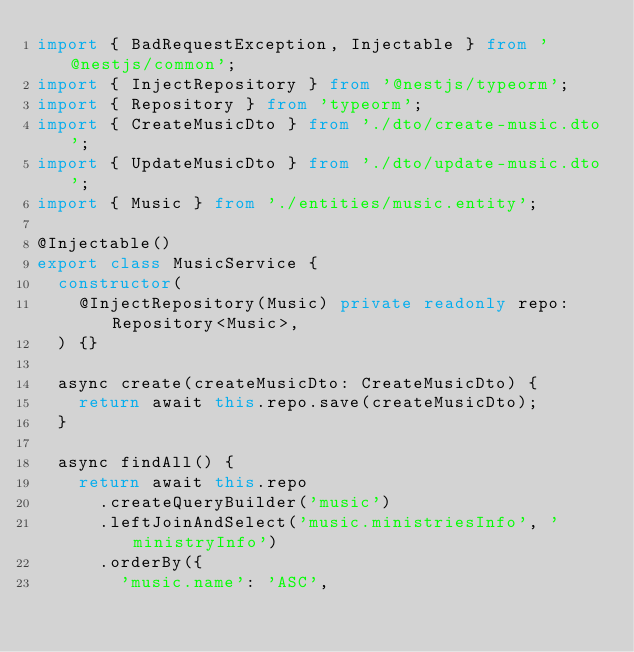Convert code to text. <code><loc_0><loc_0><loc_500><loc_500><_TypeScript_>import { BadRequestException, Injectable } from '@nestjs/common';
import { InjectRepository } from '@nestjs/typeorm';
import { Repository } from 'typeorm';
import { CreateMusicDto } from './dto/create-music.dto';
import { UpdateMusicDto } from './dto/update-music.dto';
import { Music } from './entities/music.entity';

@Injectable()
export class MusicService {
  constructor(
    @InjectRepository(Music) private readonly repo: Repository<Music>,
  ) {}

  async create(createMusicDto: CreateMusicDto) {
    return await this.repo.save(createMusicDto);
  }

  async findAll() {
    return await this.repo
      .createQueryBuilder('music')
      .leftJoinAndSelect('music.ministriesInfo', 'ministryInfo')
      .orderBy({
        'music.name': 'ASC',</code> 